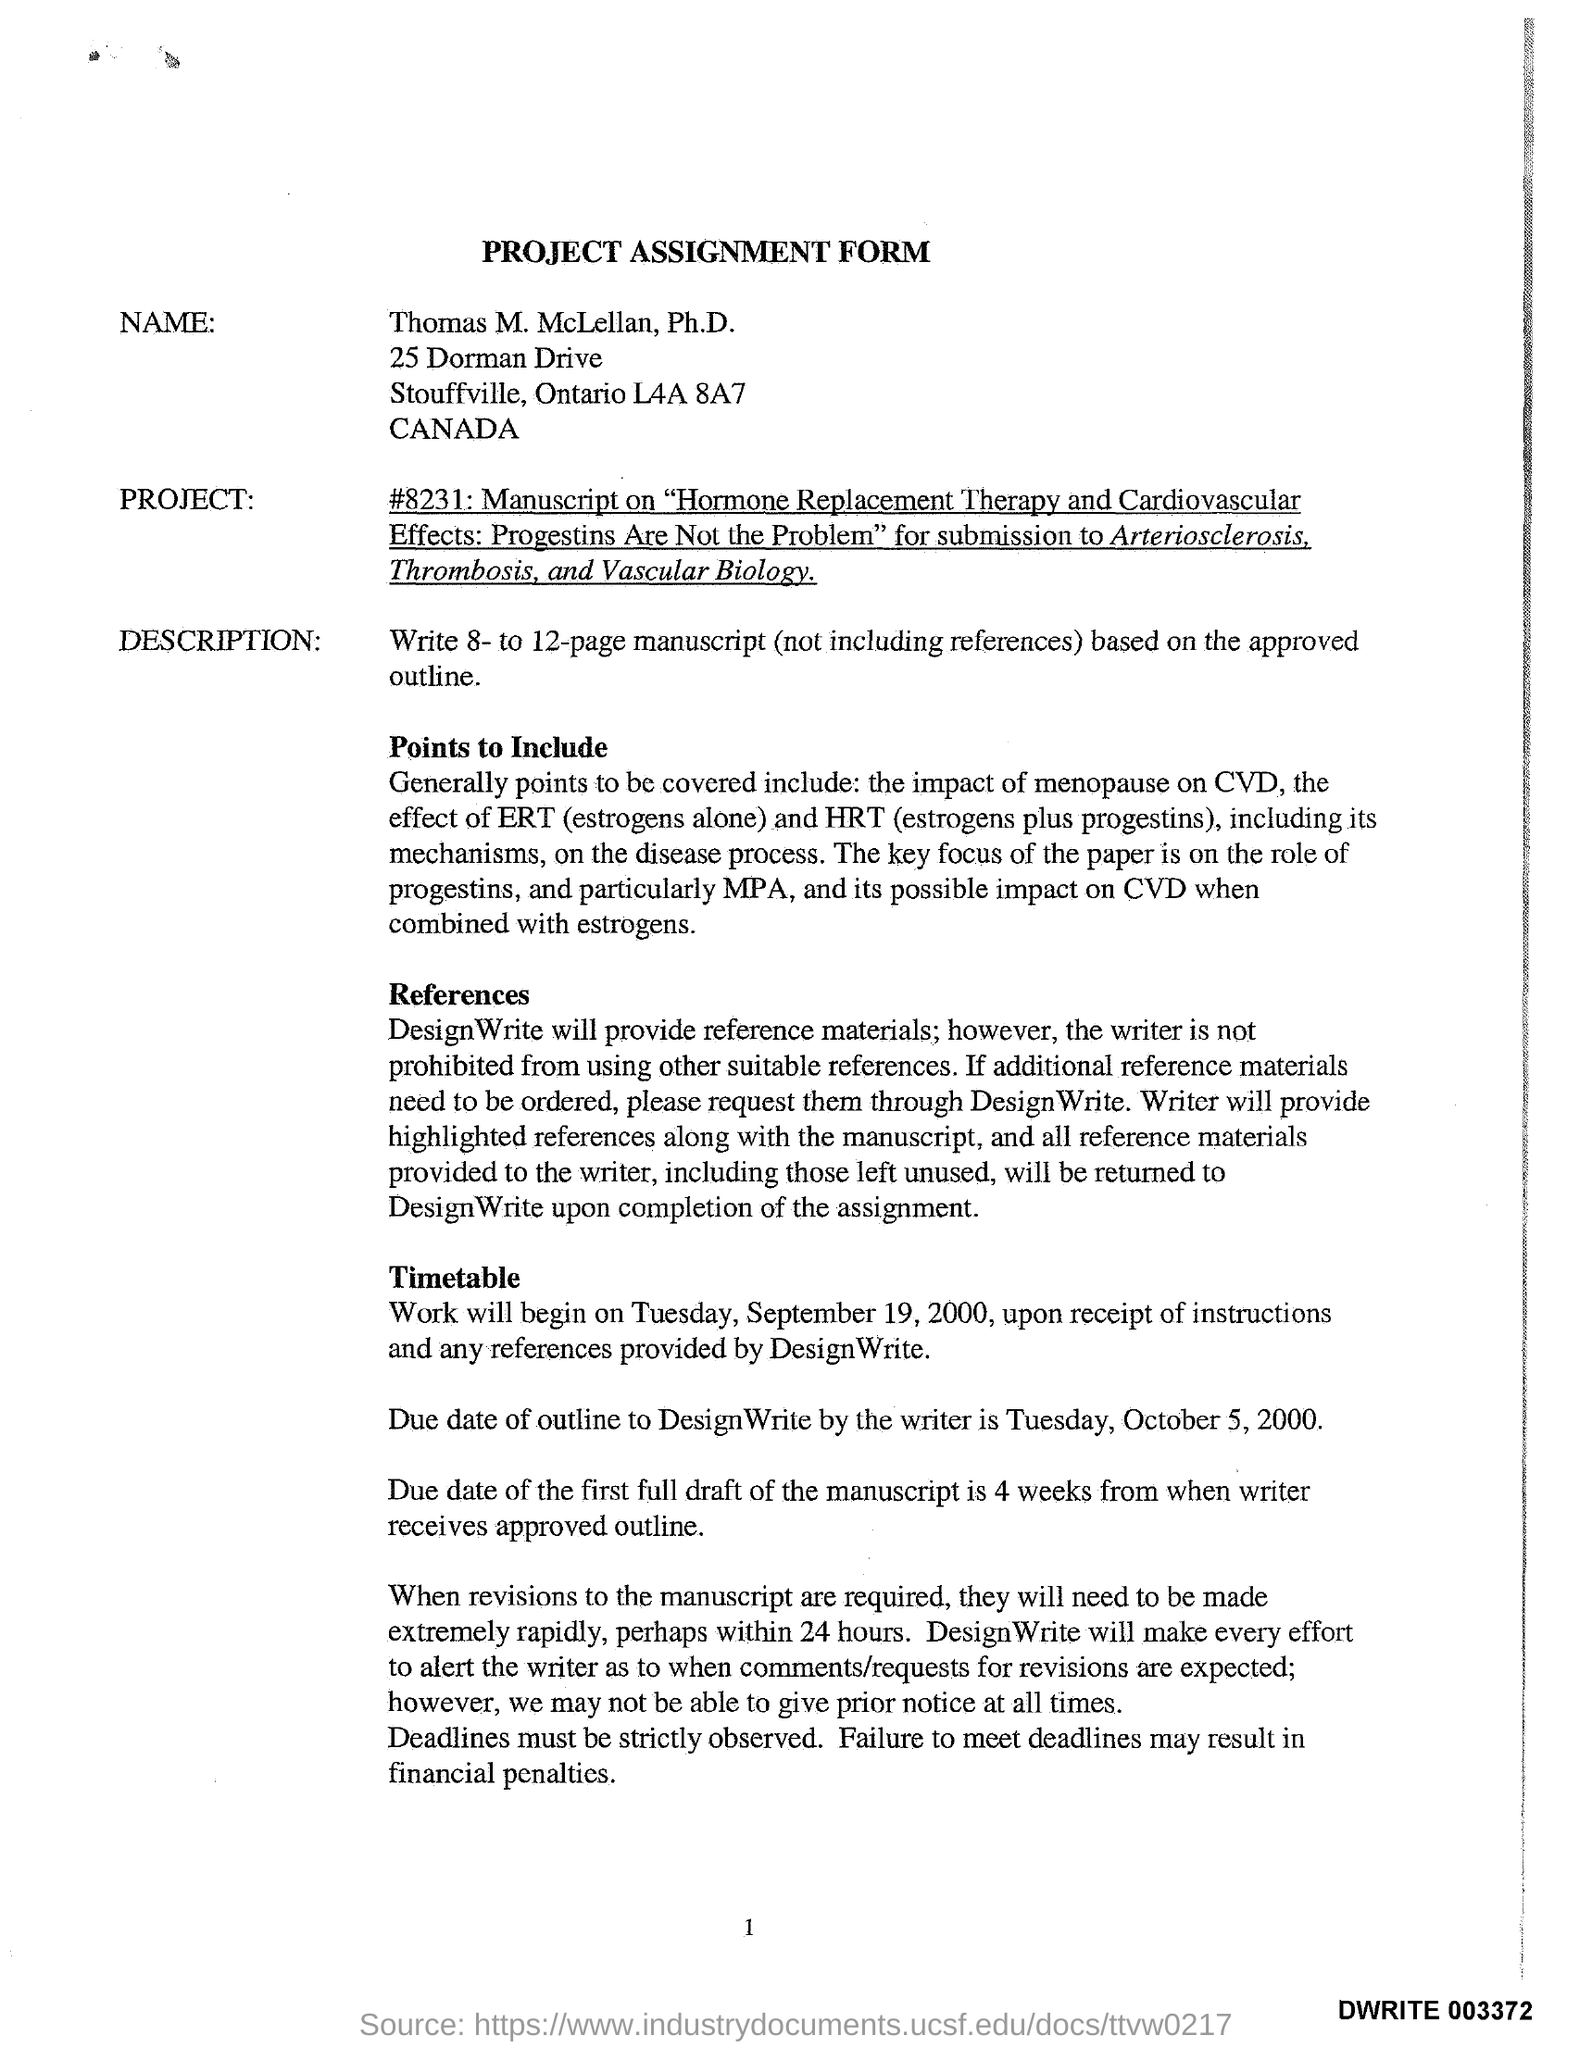Draw attention to some important aspects in this diagram. The title of the form is 'Project Assignment Form.' The individual identified on the form is named Thomas M. McLellan, Ph.D. The work shall commence on Tuesday, September 19, 2000, upon the receipt of instructions and any references provided by DesignWrite. The due date for Outline to DesignWrite by the writer is Tuesday, October 5, 2000. 